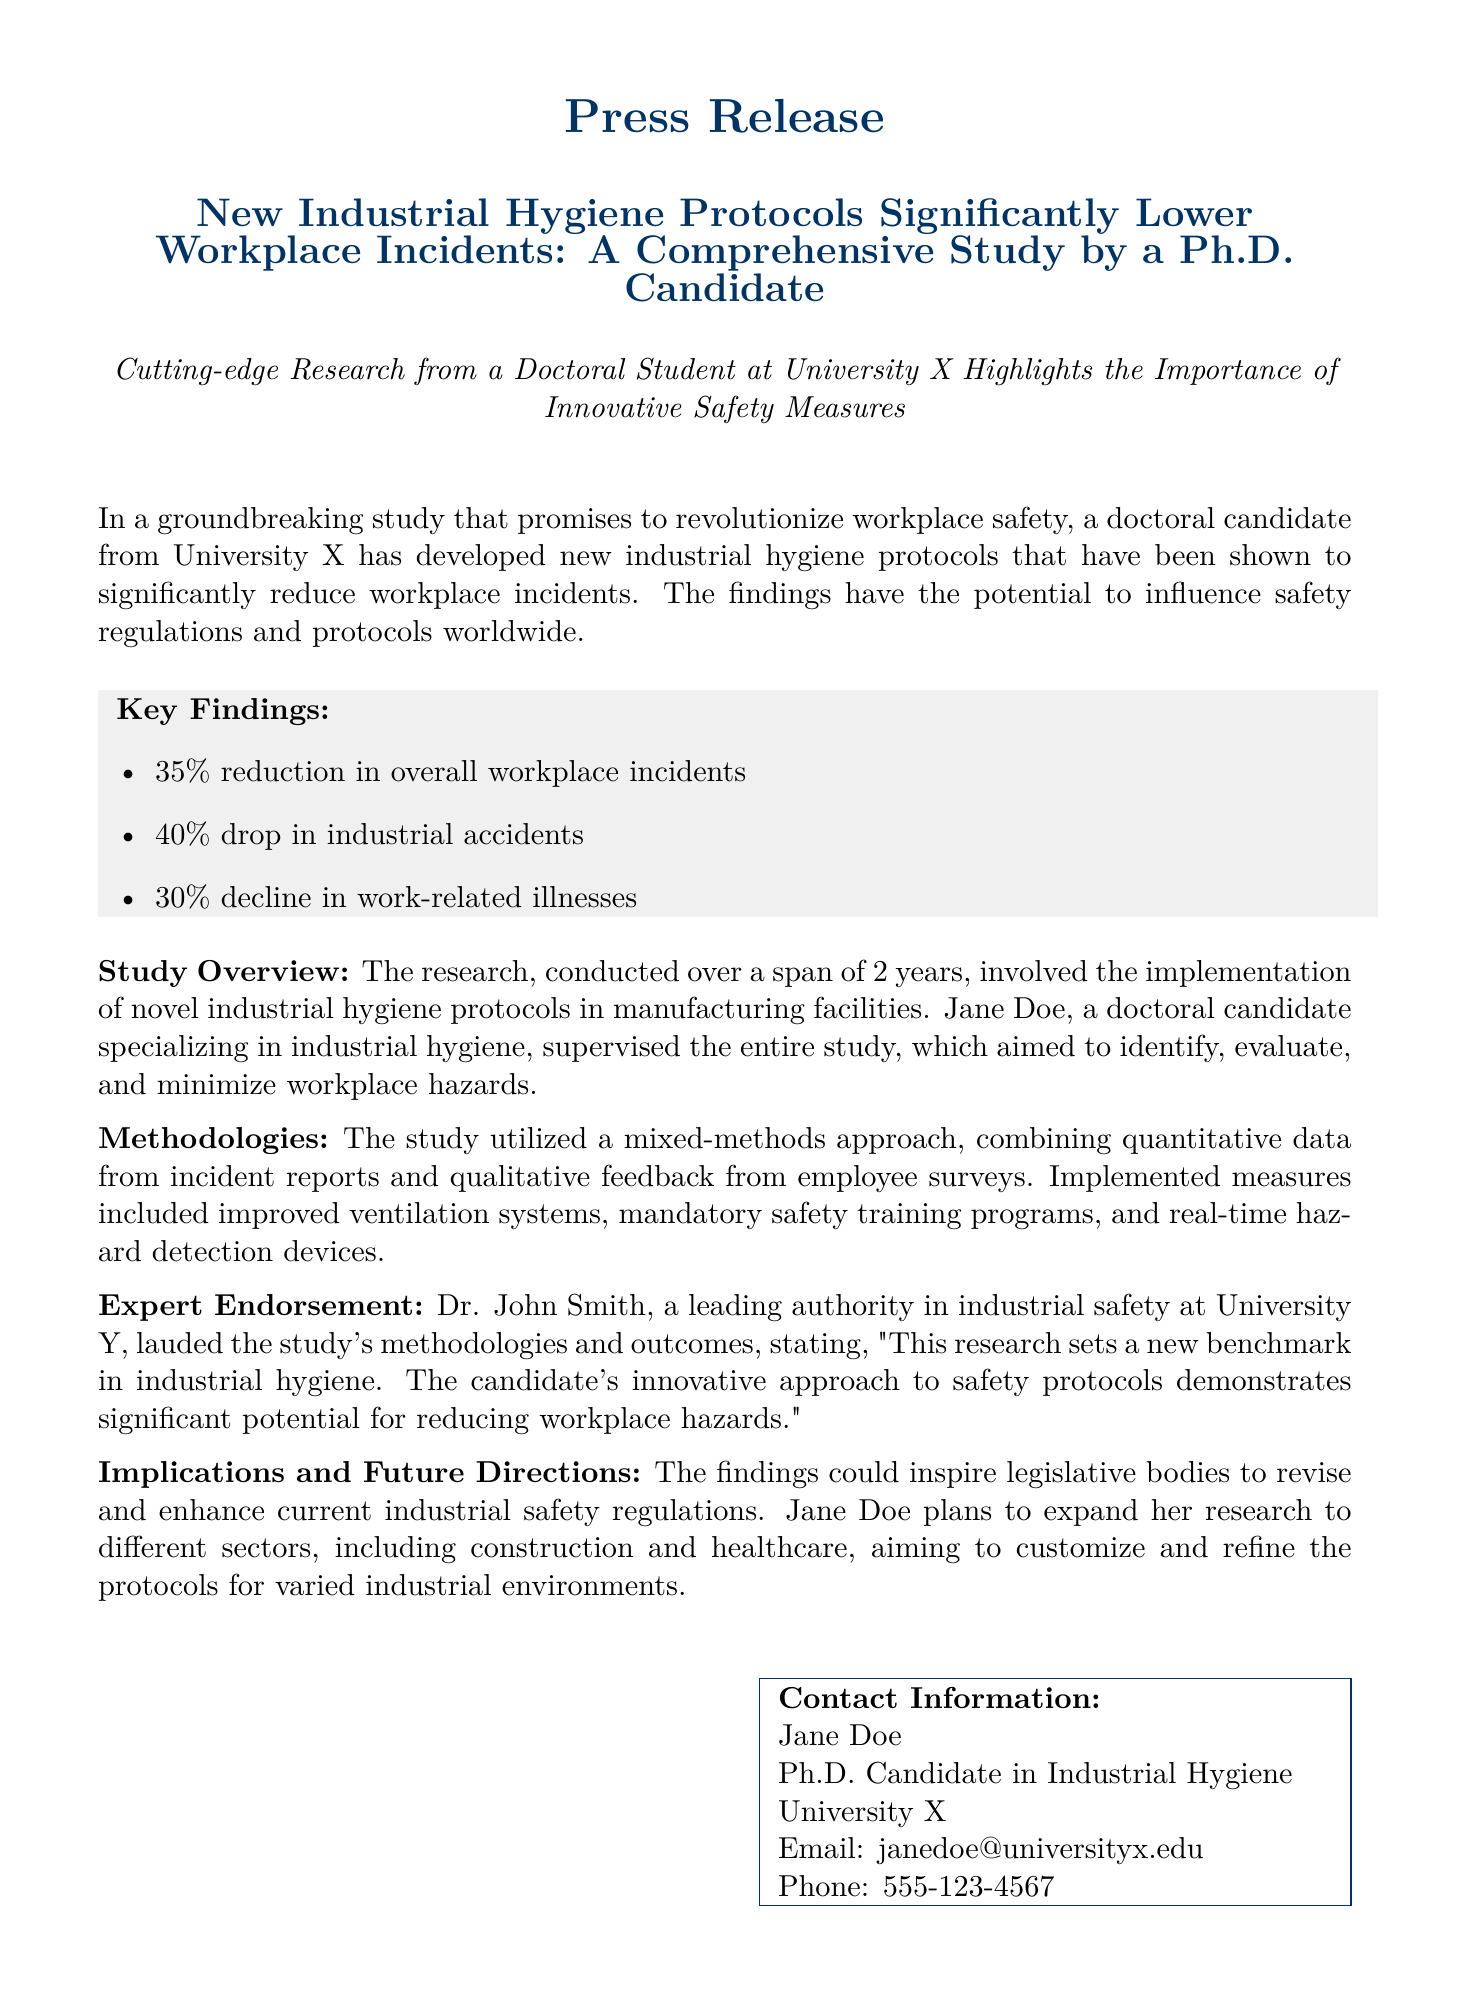what is the percentage reduction in overall workplace incidents? The document states a 35% reduction in overall workplace incidents as a key finding.
Answer: 35% who supervised the study? The study was supervised by Jane Doe, as mentioned in the overview section.
Answer: Jane Doe how long did the research span? The document indicates that the research was conducted over a span of 2 years.
Answer: 2 years what type of approach did the study utilize? The study employed a mixed-methods approach, combining both quantitative and qualitative data.
Answer: mixed-methods which facility types will the research expand to? The future research will expand to sectors including construction and healthcare.
Answer: construction and healthcare who endorsed the study? The endorsement in the document comes from Dr. John Smith, a leading authority in industrial safety.
Answer: Dr. John Smith what specific safety measure was improved according to the study? The study mentions the implementation of improved ventilation systems as one of the measures.
Answer: improved ventilation systems what was the percentage drop in industrial accidents? The study reports a 40% drop in industrial accidents as a key finding.
Answer: 40% 